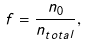<formula> <loc_0><loc_0><loc_500><loc_500>f = \frac { n _ { 0 } } { n _ { t o t a l } } ,</formula> 